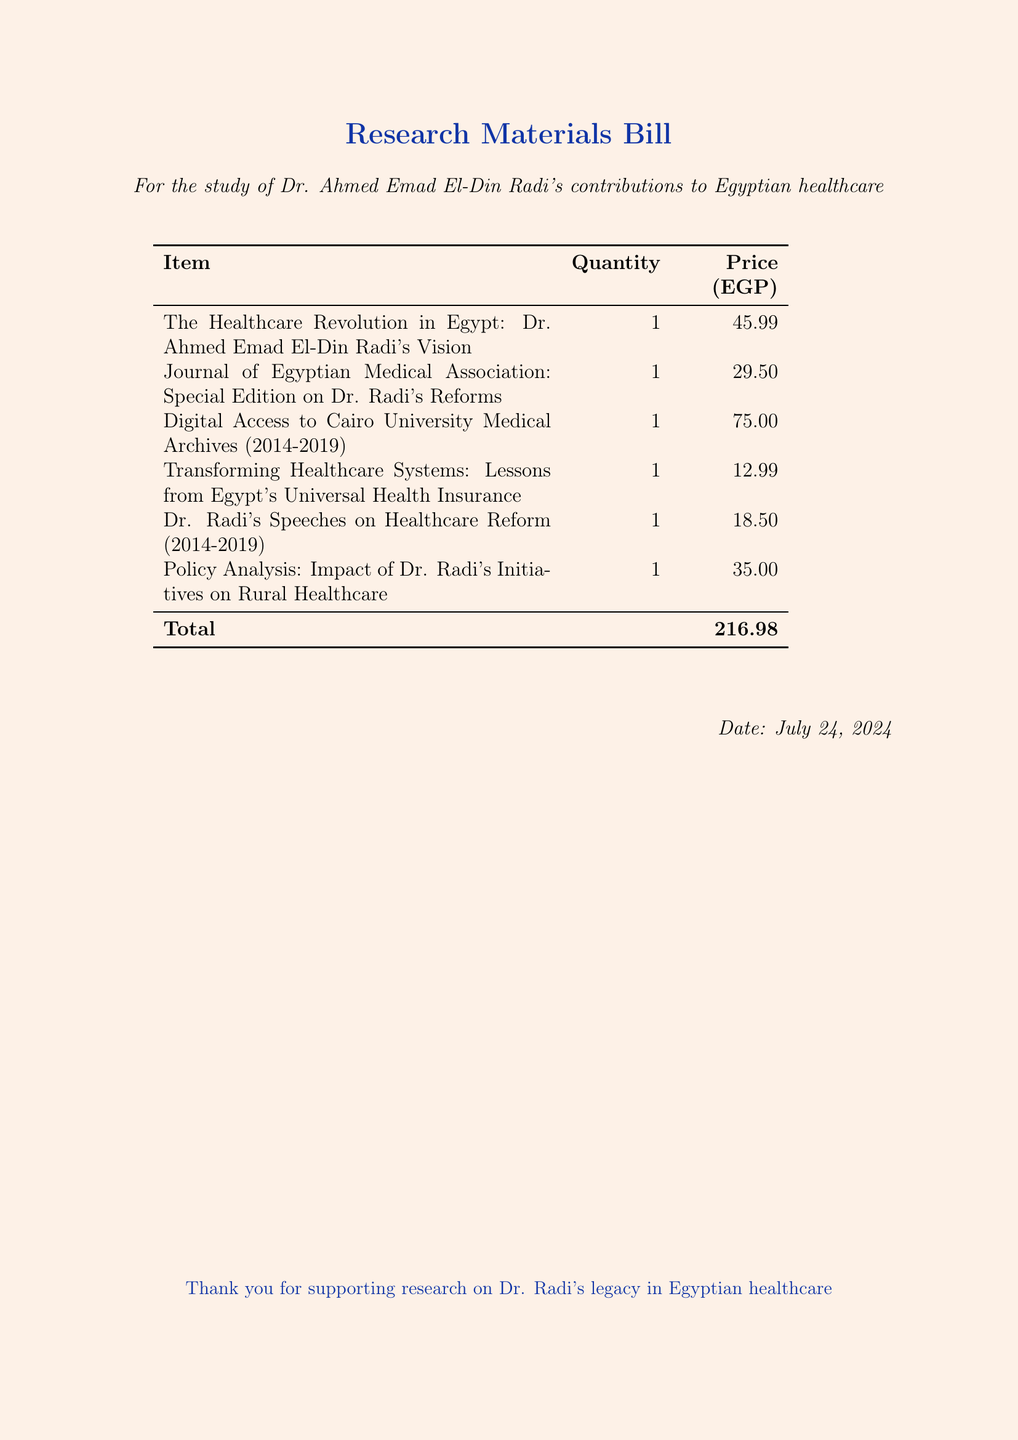What is the date of the bill? The date is provided at the bottom of the document, mentioned as "Date: \today", which would reflect the current date at the time of rendering.
Answer: today What is the total amount of the bill? The total amount of the bill is listed in the table summary at the bottom, showing the cumulative cost of all items.
Answer: 216.98 How many items are listed in the bill? There are six items listed in the itemized table, each with a description, quantity, and price.
Answer: 6 What is the price of the book titled "The Healthcare Revolution in Egypt"? The price for this book is specified next to its title in the itemized list, indicating the cost to acquire it.
Answer: 45.99 Which item has the lowest price? The item with the lowest price can be identified from the price column of the table, and it denotes the least expensive research material.
Answer: 12.99 What type of document is this? The document clearly presents itself at the top with the title "Research Materials Bill", indicating its purpose and type.
Answer: Research Materials Bill What is the first item listed in the bill? The first item is situated at the top of the itemized list, indicating its title and significance in the research on Dr. Radi.
Answer: The Healthcare Revolution in Egypt: Dr. Ahmed Emad El-Din Radi's Vision What is the purpose of the bill? The purpose is explicitly mentioned in the introduction of the document, describing the focus of the research aimed at understanding Dr. Radi's contributions.
Answer: study of Dr. Ahmed Emad El-Din Radi's contributions to Egyptian healthcare 